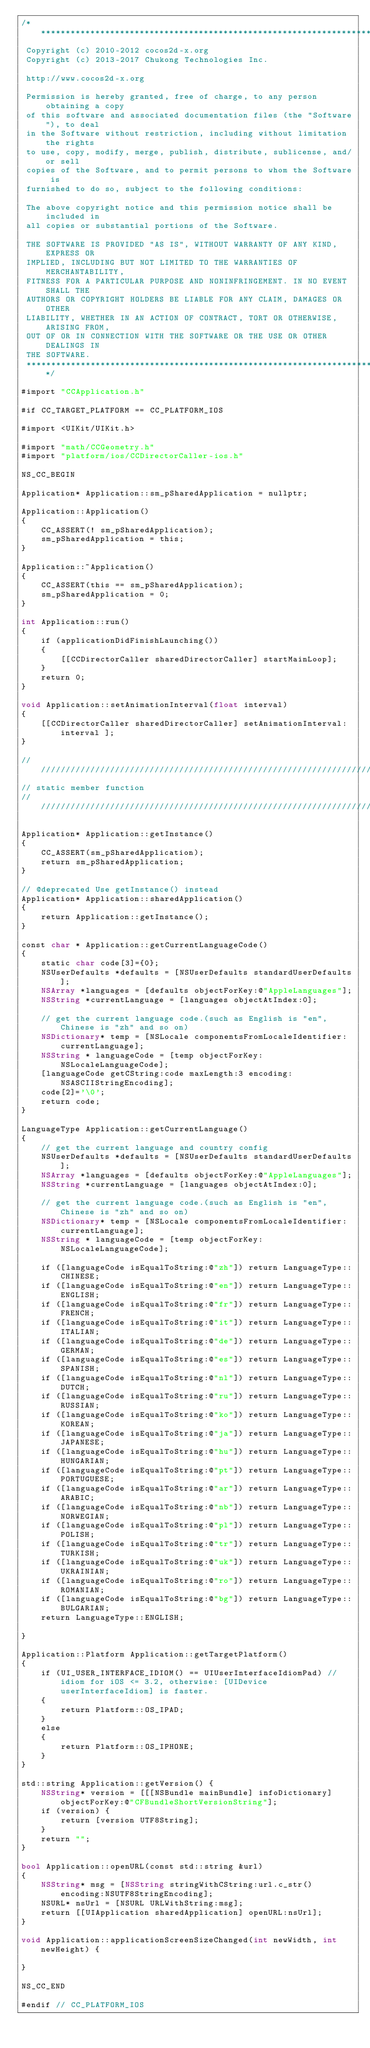<code> <loc_0><loc_0><loc_500><loc_500><_ObjectiveC_>/****************************************************************************
 Copyright (c) 2010-2012 cocos2d-x.org
 Copyright (c) 2013-2017 Chukong Technologies Inc.

 http://www.cocos2d-x.org

 Permission is hereby granted, free of charge, to any person obtaining a copy
 of this software and associated documentation files (the "Software"), to deal
 in the Software without restriction, including without limitation the rights
 to use, copy, modify, merge, publish, distribute, sublicense, and/or sell
 copies of the Software, and to permit persons to whom the Software is
 furnished to do so, subject to the following conditions:

 The above copyright notice and this permission notice shall be included in
 all copies or substantial portions of the Software.

 THE SOFTWARE IS PROVIDED "AS IS", WITHOUT WARRANTY OF ANY KIND, EXPRESS OR
 IMPLIED, INCLUDING BUT NOT LIMITED TO THE WARRANTIES OF MERCHANTABILITY,
 FITNESS FOR A PARTICULAR PURPOSE AND NONINFRINGEMENT. IN NO EVENT SHALL THE
 AUTHORS OR COPYRIGHT HOLDERS BE LIABLE FOR ANY CLAIM, DAMAGES OR OTHER
 LIABILITY, WHETHER IN AN ACTION OF CONTRACT, TORT OR OTHERWISE, ARISING FROM,
 OUT OF OR IN CONNECTION WITH THE SOFTWARE OR THE USE OR OTHER DEALINGS IN
 THE SOFTWARE.
 ****************************************************************************/

#import "CCApplication.h"

#if CC_TARGET_PLATFORM == CC_PLATFORM_IOS

#import <UIKit/UIKit.h>

#import "math/CCGeometry.h"
#import "platform/ios/CCDirectorCaller-ios.h"

NS_CC_BEGIN

Application* Application::sm_pSharedApplication = nullptr;

Application::Application()
{
    CC_ASSERT(! sm_pSharedApplication);
    sm_pSharedApplication = this;
}

Application::~Application()
{
    CC_ASSERT(this == sm_pSharedApplication);
    sm_pSharedApplication = 0;
}

int Application::run()
{
    if (applicationDidFinishLaunching())
    {
        [[CCDirectorCaller sharedDirectorCaller] startMainLoop];
    }
    return 0;
}

void Application::setAnimationInterval(float interval)
{
    [[CCDirectorCaller sharedDirectorCaller] setAnimationInterval: interval ];
}

/////////////////////////////////////////////////////////////////////////////////////////////////
// static member function
//////////////////////////////////////////////////////////////////////////////////////////////////

Application* Application::getInstance()
{
    CC_ASSERT(sm_pSharedApplication);
    return sm_pSharedApplication;
}

// @deprecated Use getInstance() instead
Application* Application::sharedApplication()
{
    return Application::getInstance();
}

const char * Application::getCurrentLanguageCode()
{
    static char code[3]={0};
    NSUserDefaults *defaults = [NSUserDefaults standardUserDefaults];
    NSArray *languages = [defaults objectForKey:@"AppleLanguages"];
    NSString *currentLanguage = [languages objectAtIndex:0];

    // get the current language code.(such as English is "en", Chinese is "zh" and so on)
    NSDictionary* temp = [NSLocale componentsFromLocaleIdentifier:currentLanguage];
    NSString * languageCode = [temp objectForKey:NSLocaleLanguageCode];
    [languageCode getCString:code maxLength:3 encoding:NSASCIIStringEncoding];
    code[2]='\0';
    return code;
}

LanguageType Application::getCurrentLanguage()
{
    // get the current language and country config
    NSUserDefaults *defaults = [NSUserDefaults standardUserDefaults];
    NSArray *languages = [defaults objectForKey:@"AppleLanguages"];
    NSString *currentLanguage = [languages objectAtIndex:0];

    // get the current language code.(such as English is "en", Chinese is "zh" and so on)
    NSDictionary* temp = [NSLocale componentsFromLocaleIdentifier:currentLanguage];
    NSString * languageCode = [temp objectForKey:NSLocaleLanguageCode];

    if ([languageCode isEqualToString:@"zh"]) return LanguageType::CHINESE;
    if ([languageCode isEqualToString:@"en"]) return LanguageType::ENGLISH;
    if ([languageCode isEqualToString:@"fr"]) return LanguageType::FRENCH;
    if ([languageCode isEqualToString:@"it"]) return LanguageType::ITALIAN;
    if ([languageCode isEqualToString:@"de"]) return LanguageType::GERMAN;
    if ([languageCode isEqualToString:@"es"]) return LanguageType::SPANISH;
    if ([languageCode isEqualToString:@"nl"]) return LanguageType::DUTCH;
    if ([languageCode isEqualToString:@"ru"]) return LanguageType::RUSSIAN;
    if ([languageCode isEqualToString:@"ko"]) return LanguageType::KOREAN;
    if ([languageCode isEqualToString:@"ja"]) return LanguageType::JAPANESE;
    if ([languageCode isEqualToString:@"hu"]) return LanguageType::HUNGARIAN;
    if ([languageCode isEqualToString:@"pt"]) return LanguageType::PORTUGUESE;
    if ([languageCode isEqualToString:@"ar"]) return LanguageType::ARABIC;
    if ([languageCode isEqualToString:@"nb"]) return LanguageType::NORWEGIAN;
    if ([languageCode isEqualToString:@"pl"]) return LanguageType::POLISH;
    if ([languageCode isEqualToString:@"tr"]) return LanguageType::TURKISH;
    if ([languageCode isEqualToString:@"uk"]) return LanguageType::UKRAINIAN;
    if ([languageCode isEqualToString:@"ro"]) return LanguageType::ROMANIAN;
    if ([languageCode isEqualToString:@"bg"]) return LanguageType::BULGARIAN;
    return LanguageType::ENGLISH;

}

Application::Platform Application::getTargetPlatform()
{
    if (UI_USER_INTERFACE_IDIOM() == UIUserInterfaceIdiomPad) // idiom for iOS <= 3.2, otherwise: [UIDevice userInterfaceIdiom] is faster.
    {
        return Platform::OS_IPAD;
    }
    else
    {
        return Platform::OS_IPHONE;
    }
}

std::string Application::getVersion() {
    NSString* version = [[[NSBundle mainBundle] infoDictionary] objectForKey:@"CFBundleShortVersionString"];
    if (version) {
        return [version UTF8String];
    }
    return "";
}

bool Application::openURL(const std::string &url)
{
    NSString* msg = [NSString stringWithCString:url.c_str() encoding:NSUTF8StringEncoding];
    NSURL* nsUrl = [NSURL URLWithString:msg];
    return [[UIApplication sharedApplication] openURL:nsUrl];
}

void Application::applicationScreenSizeChanged(int newWidth, int newHeight) {

}

NS_CC_END

#endif // CC_PLATFORM_IOS
</code> 